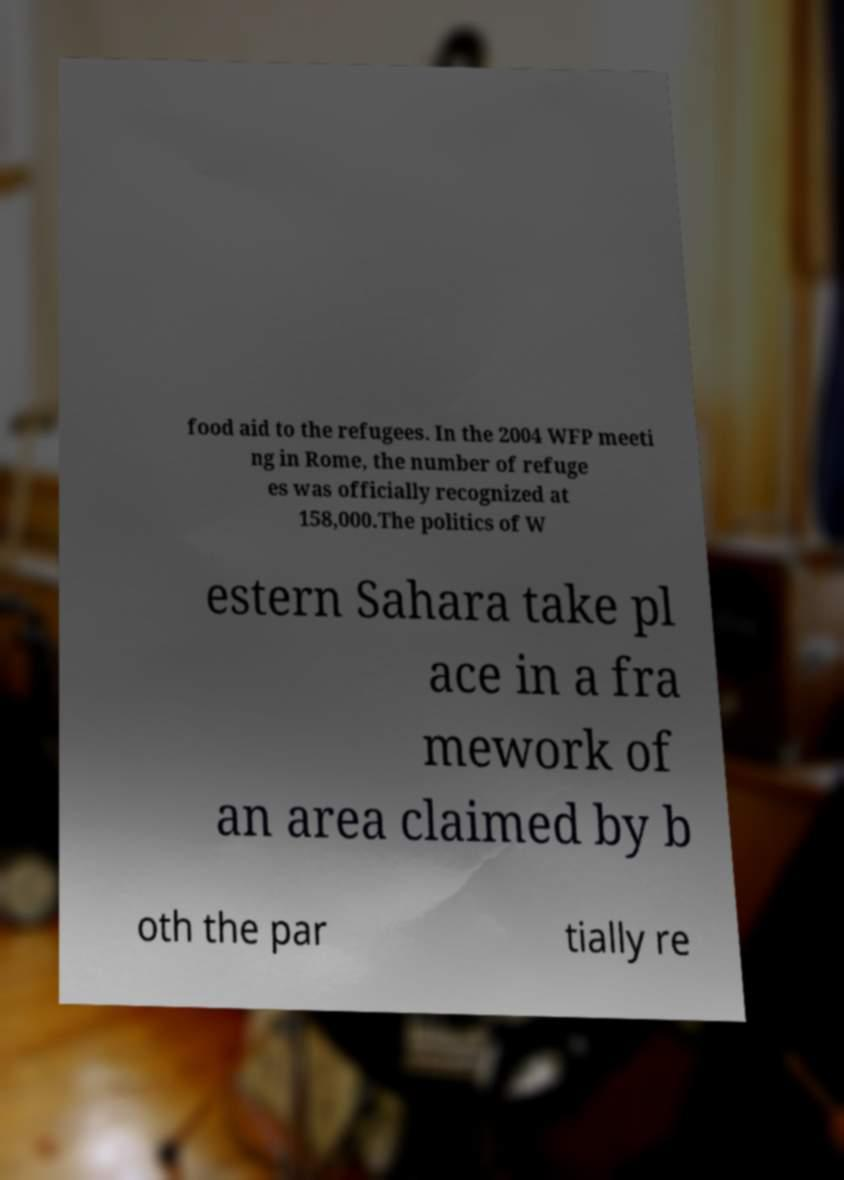For documentation purposes, I need the text within this image transcribed. Could you provide that? food aid to the refugees. In the 2004 WFP meeti ng in Rome, the number of refuge es was officially recognized at 158,000.The politics of W estern Sahara take pl ace in a fra mework of an area claimed by b oth the par tially re 